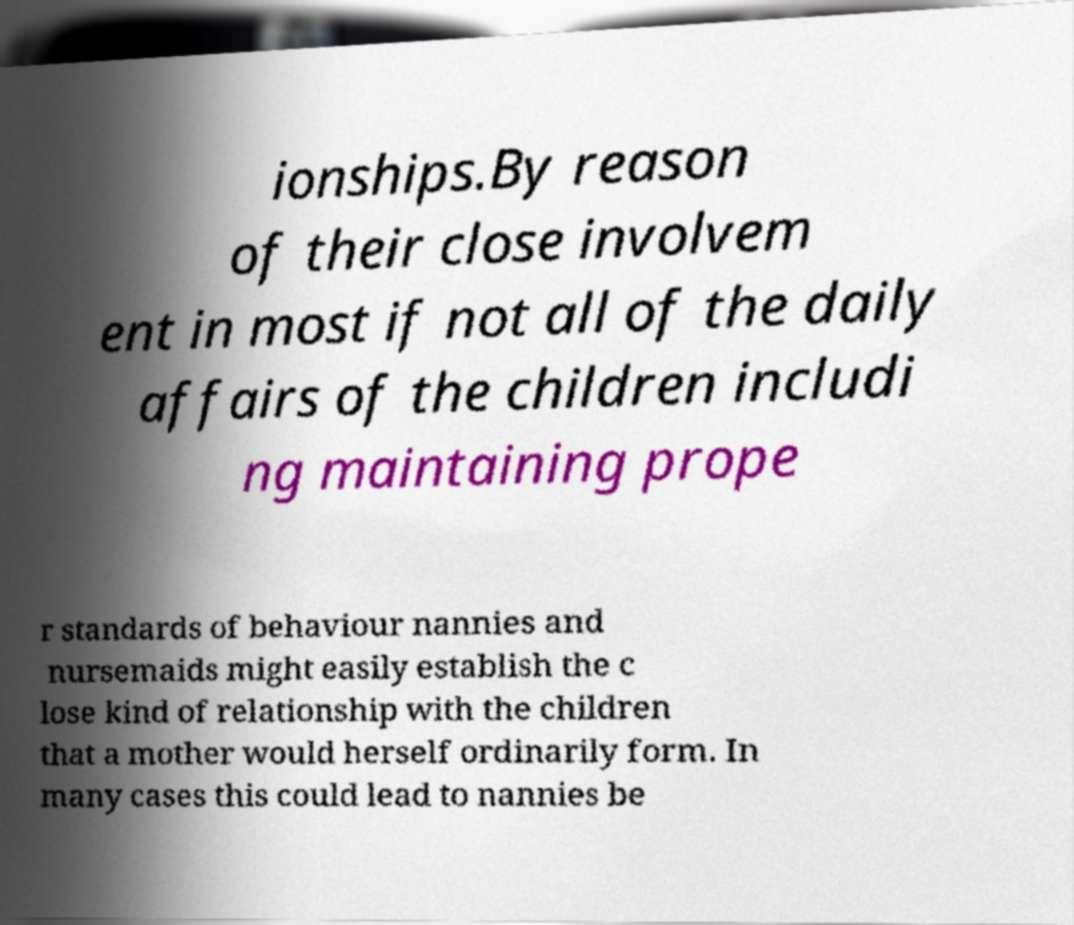I need the written content from this picture converted into text. Can you do that? ionships.By reason of their close involvem ent in most if not all of the daily affairs of the children includi ng maintaining prope r standards of behaviour nannies and nursemaids might easily establish the c lose kind of relationship with the children that a mother would herself ordinarily form. In many cases this could lead to nannies be 